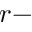Convert formula to latex. <formula><loc_0><loc_0><loc_500><loc_500>r -</formula> 